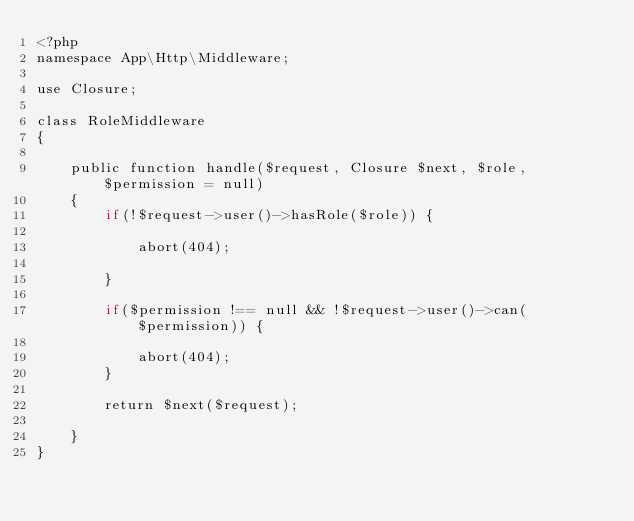Convert code to text. <code><loc_0><loc_0><loc_500><loc_500><_PHP_><?php
namespace App\Http\Middleware;

use Closure;

class RoleMiddleware
{

    public function handle($request, Closure $next, $role, $permission = null)
    {
        if(!$request->user()->hasRole($role)) {

            abort(404);

        }

        if($permission !== null && !$request->user()->can($permission)) {

            abort(404);
        }

        return $next($request);

    }
}
</code> 